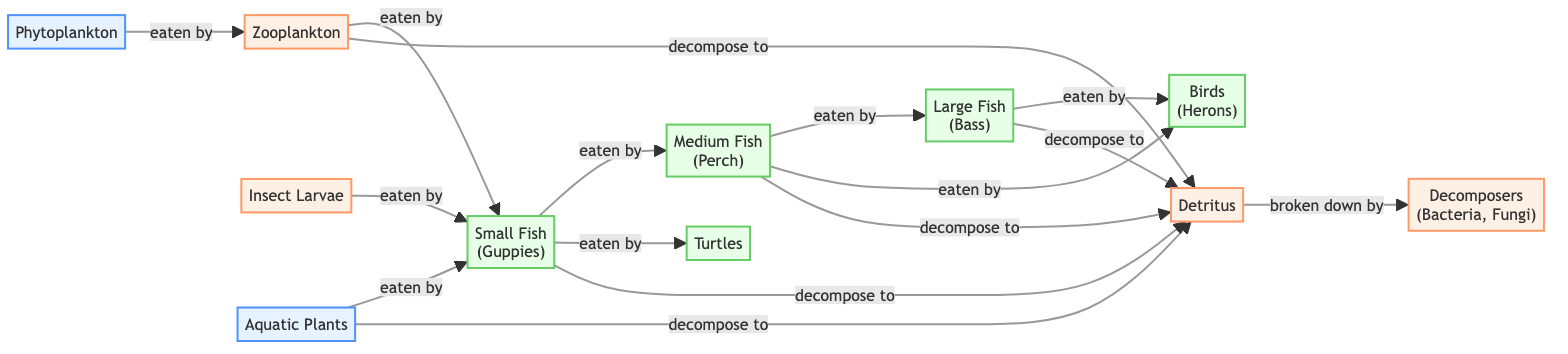What is the primary producer in this food web? The food web identifies phytoplankton and aquatic plants as the primary producers. These are at the beginning of the food chain, converting sunlight into energy.
Answer: Phytoplankton, Aquatic Plants How many tertiary consumers are present in the food web? The food web shows small fish, medium fish, large fish, turtles, and birds as the tertiary consumers. Counting these, we find there are five tertiary consumers.
Answer: 5 Which organism is eaten by both small fish and turtles? The diagram indicates that small fish feed on zooplankton and insect larvae, while turtles eat small fish, showing that small fish is a common food source for both.
Answer: Small Fish What decomposes aquatic plants in the food web? The diagram shows that aquatic plants decompose into detritus, and this detritus is then broken down by decomposers such as bacteria and fungi, illustrating the recycling of nutrients in the ecosystem.
Answer: Detritus Which fish species serves as a link between primary and secondary consumers? The diagram links zooplankton and insect larvae, which are primary consumers, to small fish, which are secondary consumers. Thus, small fish connect these groups in the food web.
Answer: Small Fish What is the relationship between medium fish and birds in the food web? In the food web, medium fish are shown to be predated by birds, establishing a predator-prey relationship between these two organisms.
Answer: Medium Fish Eaten By Birds How do large fish contribute to the food web? The diagram indicates that large fish decompose to detritus, thus contributing to nutrient cycling within the food web after they die, which supports other organisms.
Answer: Decompose to Detritus What role do decomposers play in this ecosystem? According to the diagram, decomposers like bacteria and fungi break down dead material, specifically detritus, which recycles nutrients back into the ecosystem, demonstrating their crucial role in sustaining life.
Answer: Recycle Nutrients 